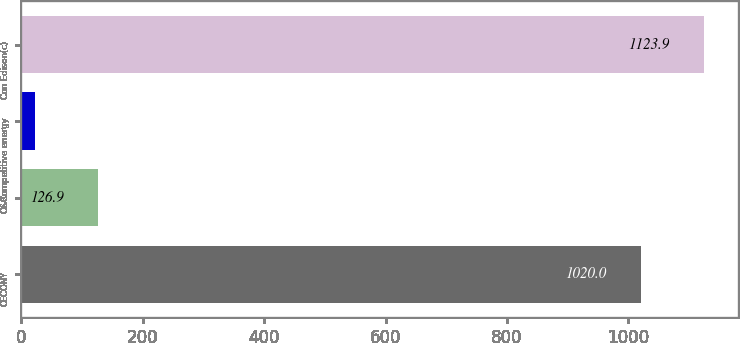Convert chart to OTSL. <chart><loc_0><loc_0><loc_500><loc_500><bar_chart><fcel>CECONY<fcel>O&R<fcel>Competitive energy<fcel>Con Edison(c)<nl><fcel>1020<fcel>126.9<fcel>23<fcel>1123.9<nl></chart> 